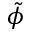<formula> <loc_0><loc_0><loc_500><loc_500>\tilde { \phi }</formula> 